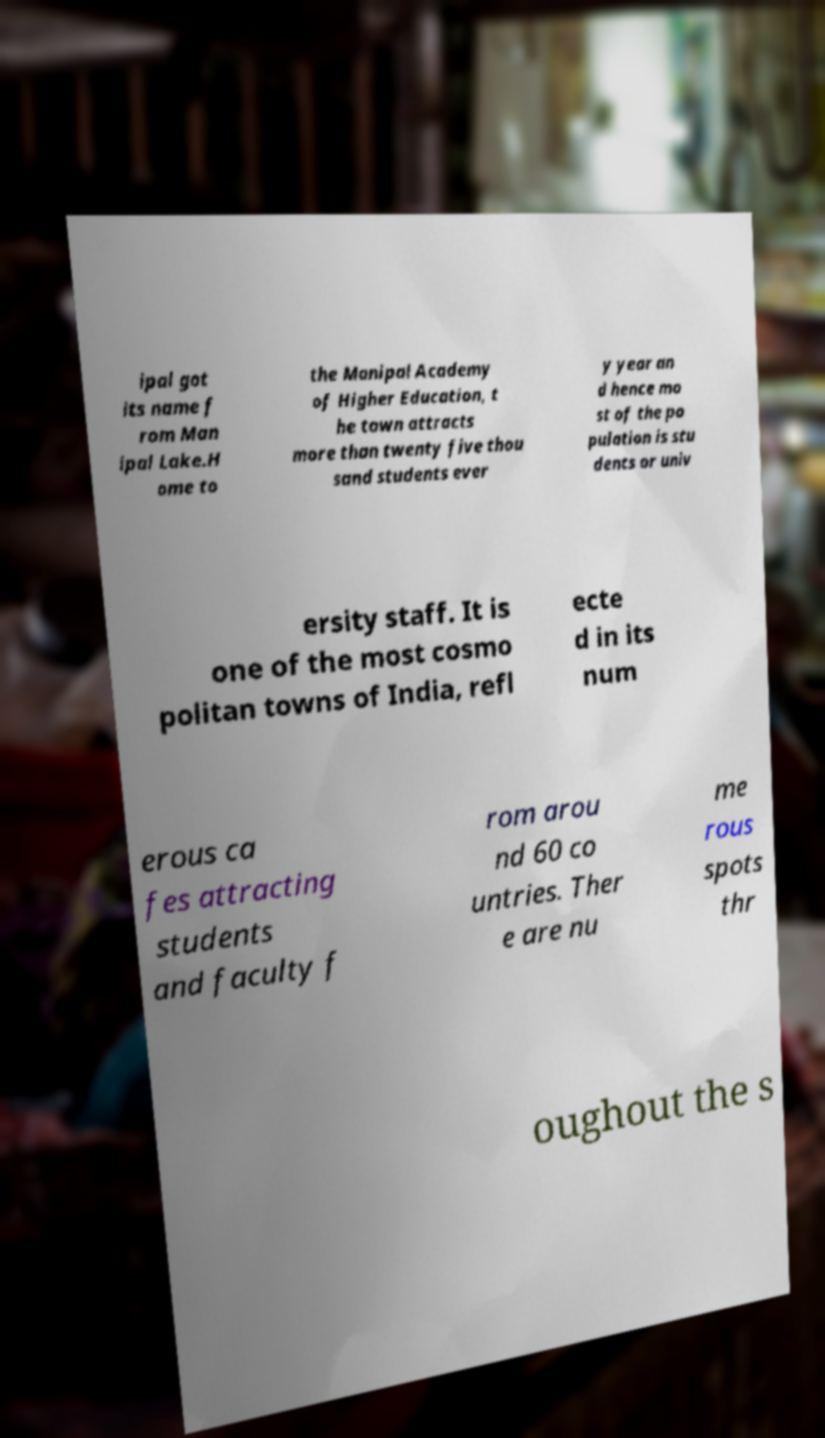Could you extract and type out the text from this image? ipal got its name f rom Man ipal Lake.H ome to the Manipal Academy of Higher Education, t he town attracts more than twenty five thou sand students ever y year an d hence mo st of the po pulation is stu dents or univ ersity staff. It is one of the most cosmo politan towns of India, refl ecte d in its num erous ca fes attracting students and faculty f rom arou nd 60 co untries. Ther e are nu me rous spots thr oughout the s 